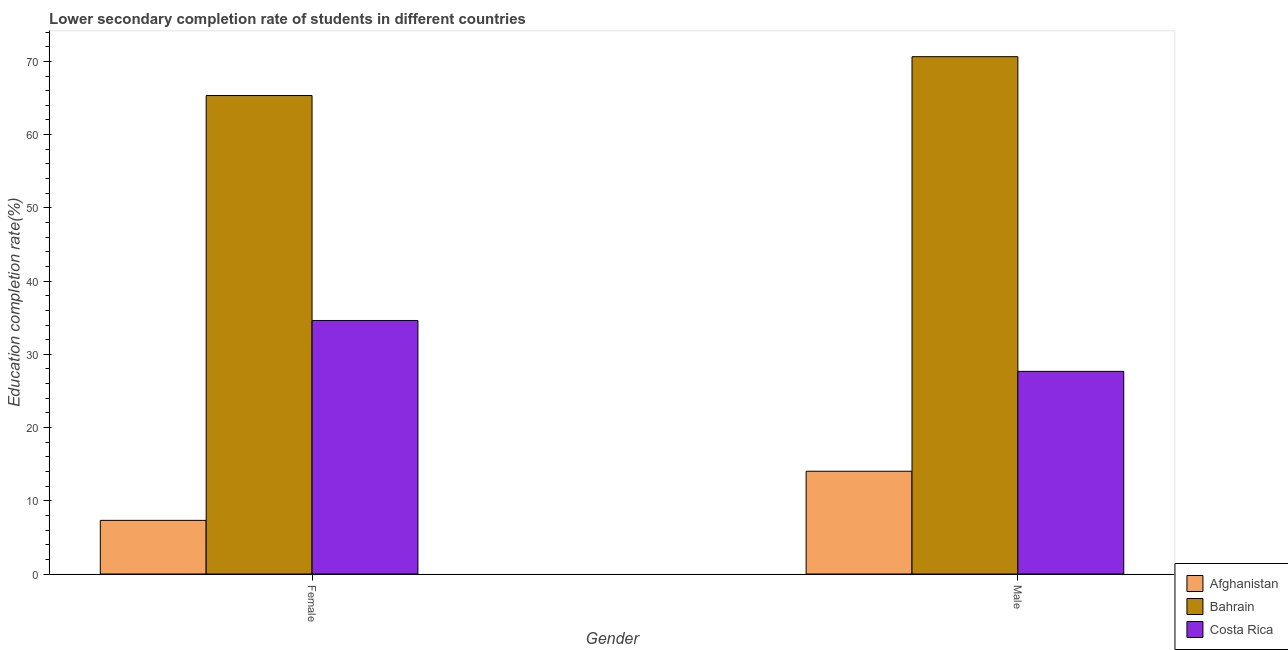How many groups of bars are there?
Provide a short and direct response. 2. Are the number of bars per tick equal to the number of legend labels?
Your answer should be very brief. Yes. How many bars are there on the 2nd tick from the left?
Your answer should be very brief. 3. How many bars are there on the 2nd tick from the right?
Keep it short and to the point. 3. What is the label of the 1st group of bars from the left?
Offer a terse response. Female. What is the education completion rate of female students in Afghanistan?
Provide a succinct answer. 7.33. Across all countries, what is the maximum education completion rate of male students?
Make the answer very short. 70.64. Across all countries, what is the minimum education completion rate of male students?
Ensure brevity in your answer.  14.03. In which country was the education completion rate of female students maximum?
Provide a succinct answer. Bahrain. In which country was the education completion rate of female students minimum?
Provide a succinct answer. Afghanistan. What is the total education completion rate of male students in the graph?
Make the answer very short. 112.35. What is the difference between the education completion rate of male students in Bahrain and that in Costa Rica?
Provide a short and direct response. 42.97. What is the difference between the education completion rate of male students in Costa Rica and the education completion rate of female students in Afghanistan?
Offer a very short reply. 20.35. What is the average education completion rate of male students per country?
Offer a terse response. 37.45. What is the difference between the education completion rate of male students and education completion rate of female students in Afghanistan?
Offer a very short reply. 6.71. In how many countries, is the education completion rate of male students greater than 46 %?
Ensure brevity in your answer.  1. What is the ratio of the education completion rate of male students in Afghanistan to that in Bahrain?
Keep it short and to the point. 0.2. In how many countries, is the education completion rate of female students greater than the average education completion rate of female students taken over all countries?
Provide a short and direct response. 1. What does the 2nd bar from the left in Male represents?
Your answer should be compact. Bahrain. What does the 2nd bar from the right in Male represents?
Your answer should be compact. Bahrain. How many bars are there?
Your response must be concise. 6. How many countries are there in the graph?
Ensure brevity in your answer.  3. Are the values on the major ticks of Y-axis written in scientific E-notation?
Ensure brevity in your answer.  No. Where does the legend appear in the graph?
Provide a succinct answer. Bottom right. What is the title of the graph?
Provide a succinct answer. Lower secondary completion rate of students in different countries. What is the label or title of the X-axis?
Make the answer very short. Gender. What is the label or title of the Y-axis?
Keep it short and to the point. Education completion rate(%). What is the Education completion rate(%) of Afghanistan in Female?
Give a very brief answer. 7.33. What is the Education completion rate(%) in Bahrain in Female?
Ensure brevity in your answer.  65.34. What is the Education completion rate(%) in Costa Rica in Female?
Provide a succinct answer. 34.62. What is the Education completion rate(%) of Afghanistan in Male?
Your answer should be compact. 14.03. What is the Education completion rate(%) in Bahrain in Male?
Keep it short and to the point. 70.64. What is the Education completion rate(%) of Costa Rica in Male?
Give a very brief answer. 27.67. Across all Gender, what is the maximum Education completion rate(%) in Afghanistan?
Give a very brief answer. 14.03. Across all Gender, what is the maximum Education completion rate(%) of Bahrain?
Give a very brief answer. 70.64. Across all Gender, what is the maximum Education completion rate(%) of Costa Rica?
Provide a short and direct response. 34.62. Across all Gender, what is the minimum Education completion rate(%) of Afghanistan?
Make the answer very short. 7.33. Across all Gender, what is the minimum Education completion rate(%) of Bahrain?
Ensure brevity in your answer.  65.34. Across all Gender, what is the minimum Education completion rate(%) in Costa Rica?
Your answer should be compact. 27.67. What is the total Education completion rate(%) in Afghanistan in the graph?
Offer a terse response. 21.36. What is the total Education completion rate(%) of Bahrain in the graph?
Offer a terse response. 135.98. What is the total Education completion rate(%) of Costa Rica in the graph?
Your answer should be compact. 62.29. What is the difference between the Education completion rate(%) in Afghanistan in Female and that in Male?
Your answer should be very brief. -6.71. What is the difference between the Education completion rate(%) of Bahrain in Female and that in Male?
Offer a very short reply. -5.3. What is the difference between the Education completion rate(%) in Costa Rica in Female and that in Male?
Make the answer very short. 6.95. What is the difference between the Education completion rate(%) in Afghanistan in Female and the Education completion rate(%) in Bahrain in Male?
Offer a terse response. -63.32. What is the difference between the Education completion rate(%) of Afghanistan in Female and the Education completion rate(%) of Costa Rica in Male?
Offer a very short reply. -20.35. What is the difference between the Education completion rate(%) in Bahrain in Female and the Education completion rate(%) in Costa Rica in Male?
Ensure brevity in your answer.  37.67. What is the average Education completion rate(%) of Afghanistan per Gender?
Ensure brevity in your answer.  10.68. What is the average Education completion rate(%) in Bahrain per Gender?
Ensure brevity in your answer.  67.99. What is the average Education completion rate(%) in Costa Rica per Gender?
Offer a very short reply. 31.15. What is the difference between the Education completion rate(%) of Afghanistan and Education completion rate(%) of Bahrain in Female?
Ensure brevity in your answer.  -58.02. What is the difference between the Education completion rate(%) in Afghanistan and Education completion rate(%) in Costa Rica in Female?
Make the answer very short. -27.29. What is the difference between the Education completion rate(%) in Bahrain and Education completion rate(%) in Costa Rica in Female?
Give a very brief answer. 30.72. What is the difference between the Education completion rate(%) of Afghanistan and Education completion rate(%) of Bahrain in Male?
Ensure brevity in your answer.  -56.61. What is the difference between the Education completion rate(%) in Afghanistan and Education completion rate(%) in Costa Rica in Male?
Ensure brevity in your answer.  -13.64. What is the difference between the Education completion rate(%) in Bahrain and Education completion rate(%) in Costa Rica in Male?
Provide a short and direct response. 42.97. What is the ratio of the Education completion rate(%) in Afghanistan in Female to that in Male?
Offer a terse response. 0.52. What is the ratio of the Education completion rate(%) in Bahrain in Female to that in Male?
Give a very brief answer. 0.92. What is the ratio of the Education completion rate(%) in Costa Rica in Female to that in Male?
Your response must be concise. 1.25. What is the difference between the highest and the second highest Education completion rate(%) in Afghanistan?
Make the answer very short. 6.71. What is the difference between the highest and the second highest Education completion rate(%) in Bahrain?
Keep it short and to the point. 5.3. What is the difference between the highest and the second highest Education completion rate(%) in Costa Rica?
Keep it short and to the point. 6.95. What is the difference between the highest and the lowest Education completion rate(%) of Afghanistan?
Keep it short and to the point. 6.71. What is the difference between the highest and the lowest Education completion rate(%) in Bahrain?
Give a very brief answer. 5.3. What is the difference between the highest and the lowest Education completion rate(%) of Costa Rica?
Offer a very short reply. 6.95. 